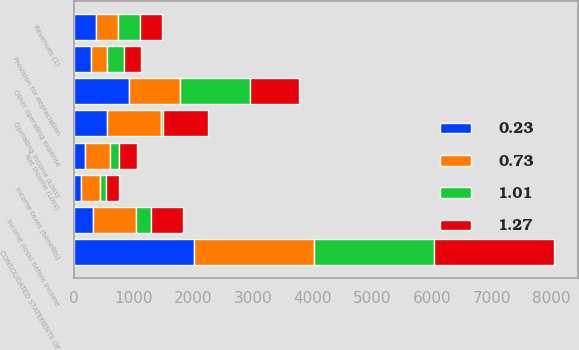<chart> <loc_0><loc_0><loc_500><loc_500><stacked_bar_chart><ecel><fcel>CONSOLIDATED STATEMENTS OF<fcel>Revenues (1)<fcel>Other operating expense<fcel>Provision for depreciation<fcel>Operating Income (Loss)<fcel>Income (loss) before income<fcel>Income taxes (benefits)<fcel>Net Income (Loss)<nl><fcel>1.01<fcel>2012<fcel>370<fcel>1165<fcel>287<fcel>34<fcel>253<fcel>105<fcel>148<nl><fcel>0.73<fcel>2012<fcel>370<fcel>865<fcel>273<fcel>907<fcel>734<fcel>309<fcel>425<nl><fcel>0.23<fcel>2012<fcel>370<fcel>921<fcel>285<fcel>557<fcel>315<fcel>127<fcel>188<nl><fcel>1.27<fcel>2012<fcel>370<fcel>818<fcel>279<fcel>746<fcel>528<fcel>222<fcel>306<nl></chart> 